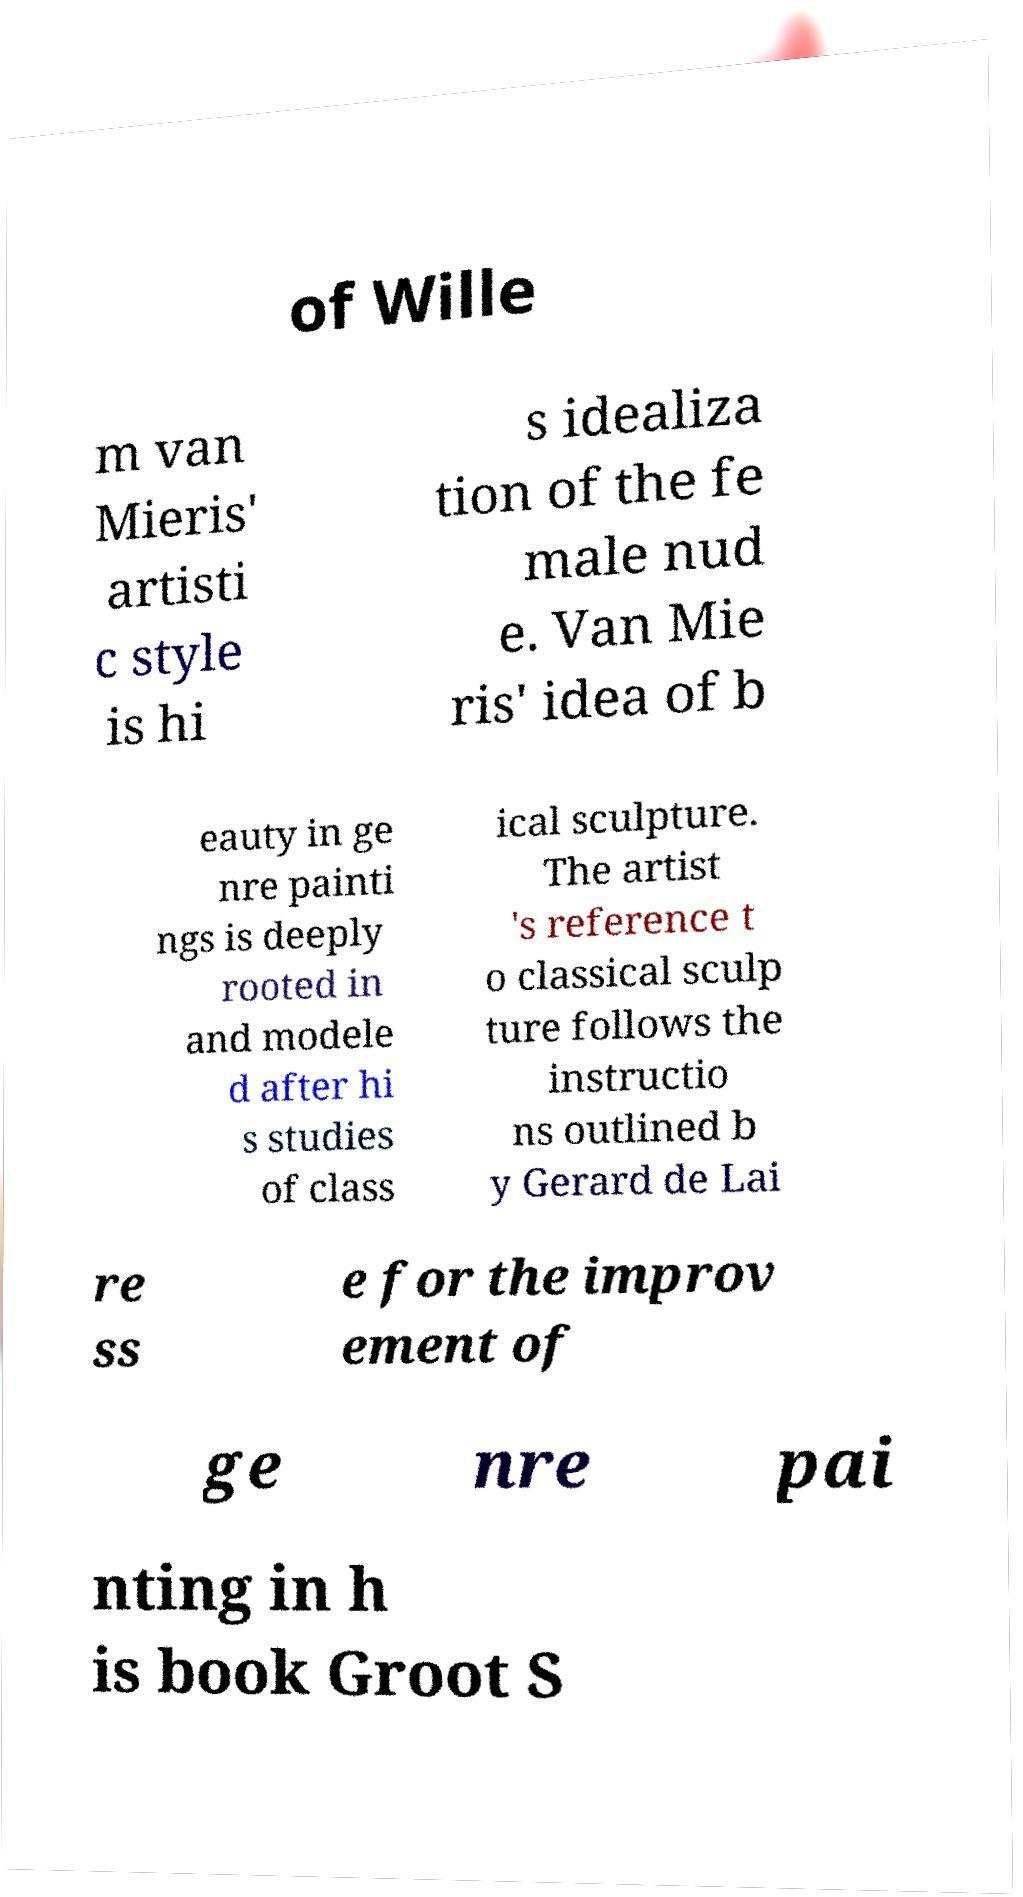There's text embedded in this image that I need extracted. Can you transcribe it verbatim? of Wille m van Mieris' artisti c style is hi s idealiza tion of the fe male nud e. Van Mie ris' idea of b eauty in ge nre painti ngs is deeply rooted in and modele d after hi s studies of class ical sculpture. The artist 's reference t o classical sculp ture follows the instructio ns outlined b y Gerard de Lai re ss e for the improv ement of ge nre pai nting in h is book Groot S 